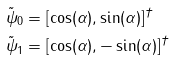<formula> <loc_0><loc_0><loc_500><loc_500>\tilde { \psi } _ { 0 } & = [ \cos ( \alpha ) , \sin ( \alpha ) ] ^ { \dagger } \\ \tilde { \psi } _ { 1 } & = [ \cos ( \alpha ) , - \sin ( \alpha ) ] ^ { \dagger }</formula> 